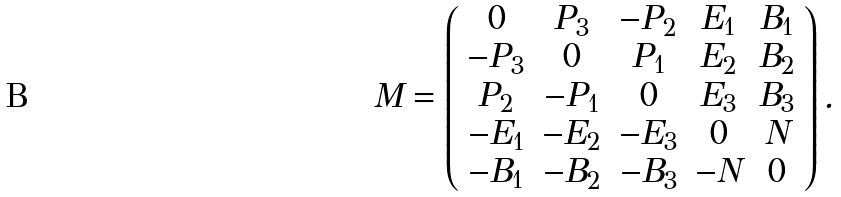Convert formula to latex. <formula><loc_0><loc_0><loc_500><loc_500>M = \left ( \begin{array} { c c c c c } 0 & P _ { 3 } & - P _ { 2 } & E _ { 1 } & B _ { 1 } \\ - P _ { 3 } & 0 & P _ { 1 } & E _ { 2 } & B _ { 2 } \\ P _ { 2 } & - P _ { 1 } & 0 & E _ { 3 } & B _ { 3 } \\ - E _ { 1 } & - E _ { 2 } & - E _ { 3 } & 0 & N \\ - B _ { 1 } & - B _ { 2 } & - B _ { 3 } & - N & 0 \end{array} \right ) .</formula> 